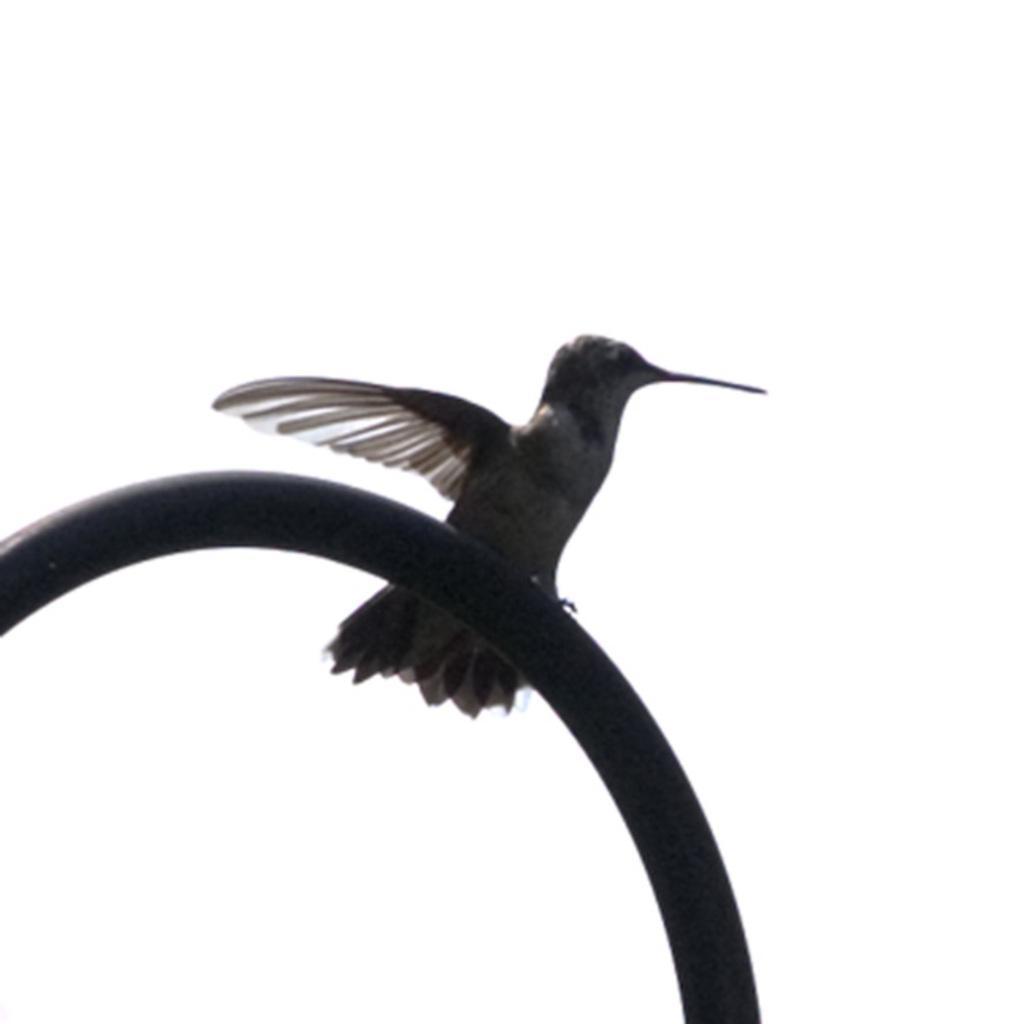Could you give a brief overview of what you see in this image? In this image we can see a bird on the pipeline. 